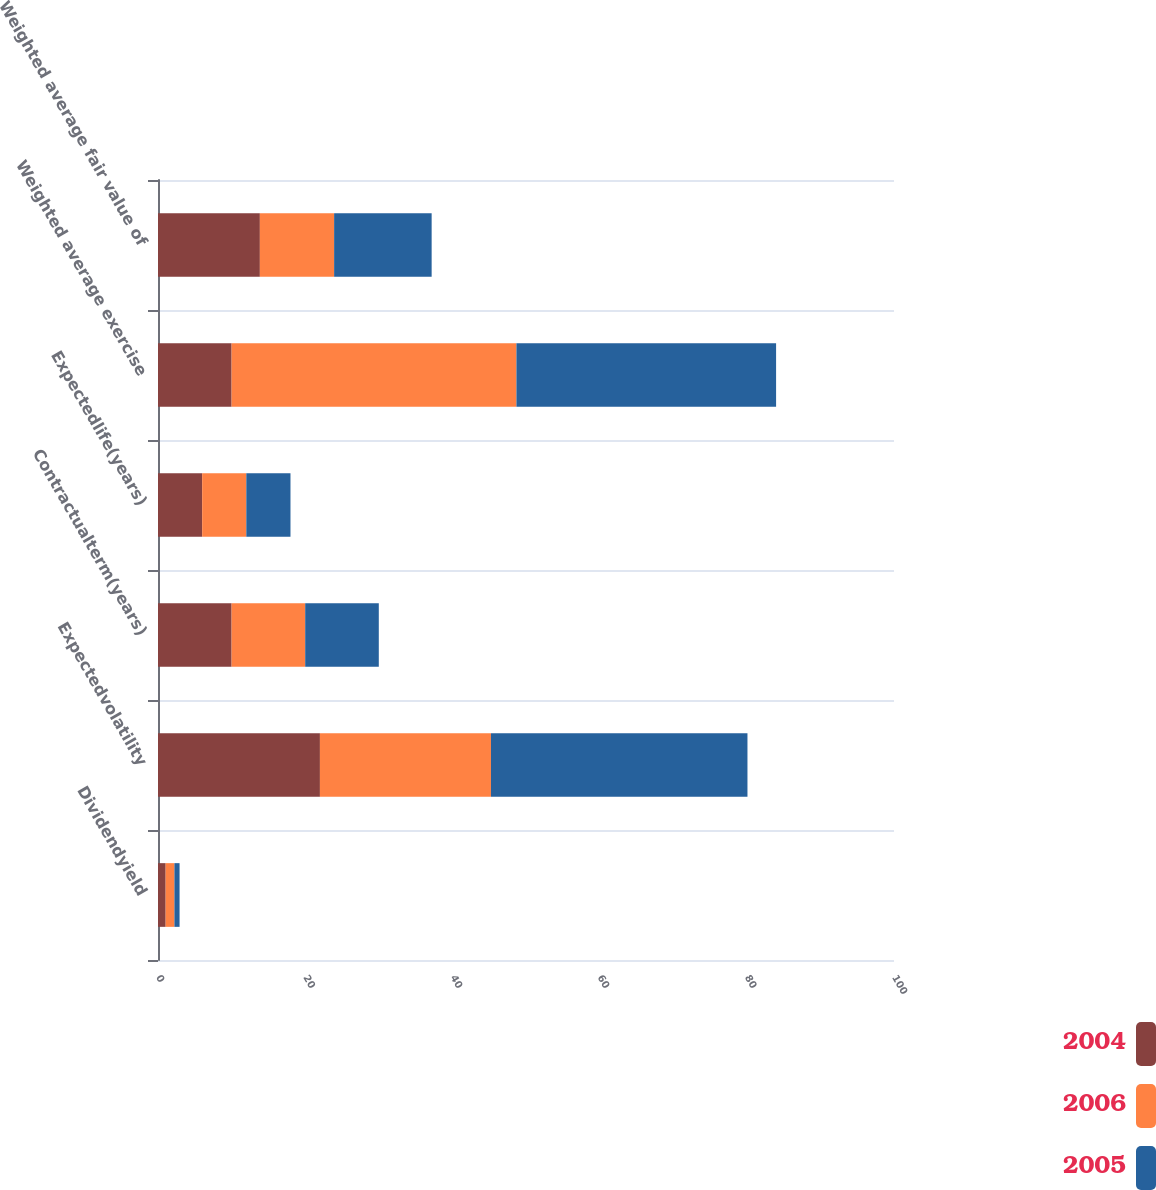Convert chart to OTSL. <chart><loc_0><loc_0><loc_500><loc_500><stacked_bar_chart><ecel><fcel>Dividendyield<fcel>Expectedvolatility<fcel>Contractualterm(years)<fcel>Expectedlife(years)<fcel>Weighted average exercise<fcel>Weighted average fair value of<nl><fcel>2004<fcel>1.04<fcel>22<fcel>10<fcel>6<fcel>10<fcel>13.84<nl><fcel>2006<fcel>1.19<fcel>23.24<fcel>10<fcel>6<fcel>38.7<fcel>10.09<nl><fcel>2005<fcel>0.7<fcel>34.85<fcel>10<fcel>6<fcel>35.28<fcel>13.25<nl></chart> 